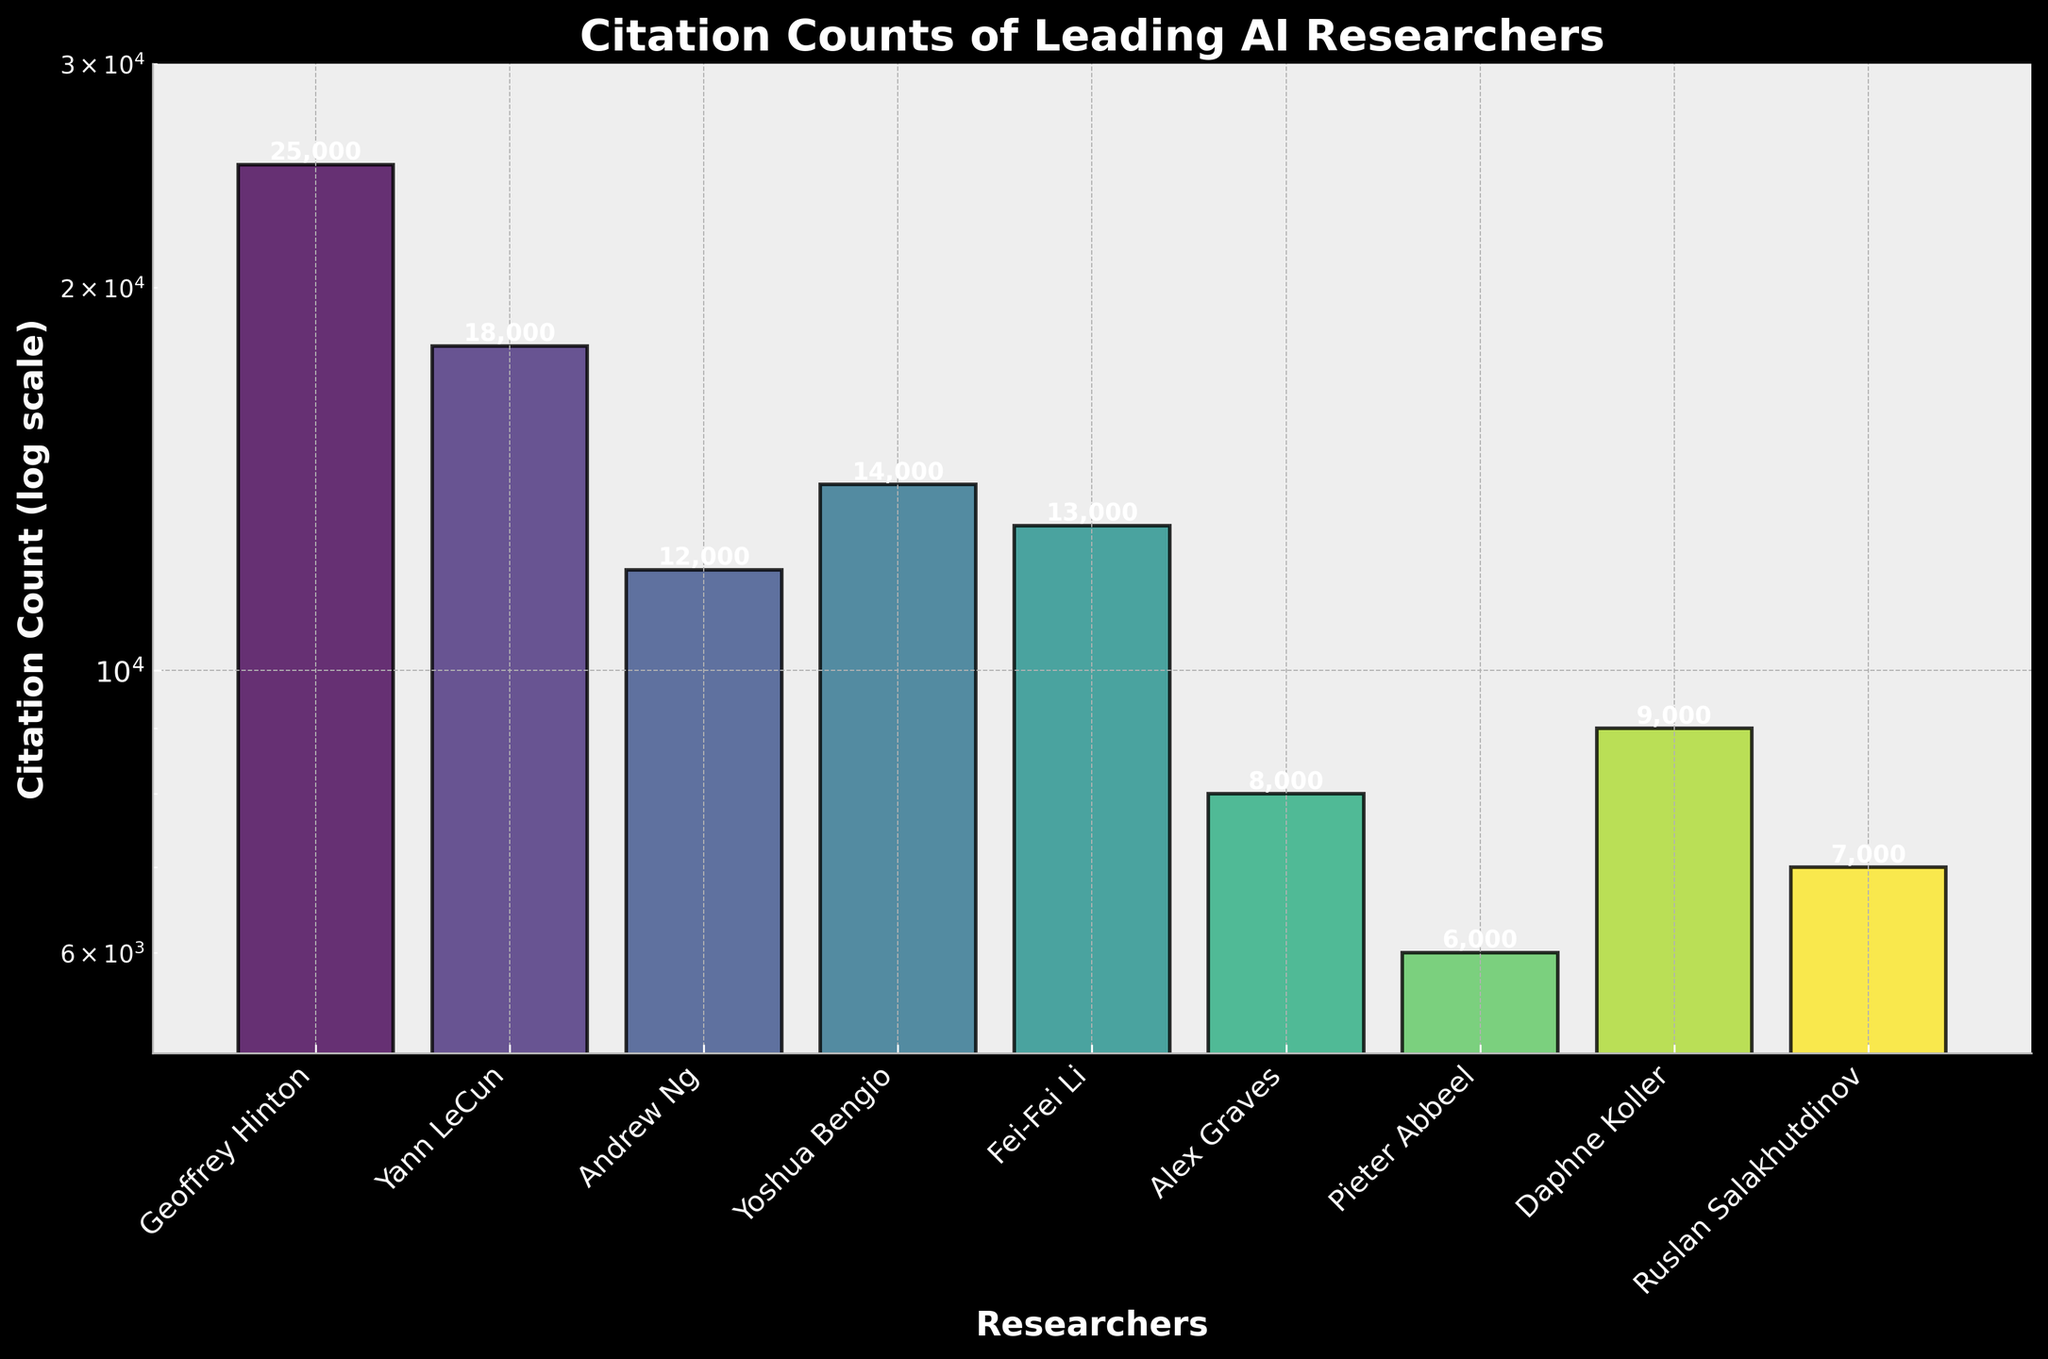what is the title of the figure? The title is usually located at the top of the figure, summarizing what the figure is about.
Answer: Citation Counts of Leading AI Researchers how many researchers have their citation counts displayed in the plot? Count the number of distinct names on the x-axis.
Answer: 9 which researcher has the highest citation count? Look for the bar that reaches the highest value on the y-axis.
Answer: Geoffrey Hinton which researcher has the lowest citation count? Identify the shortest bar on the plot.
Answer: Pieter Abbeel how many researchers have citation counts above 10,000? Count the number of bars that exceed the 10,000 mark on the y-axis.
Answer: 5 what’s the citation count difference between Andrew Ng and Daphne Koller? Subtract Koller’s citation count from Ng’s citation count. 12000 - 9000
Answer: 3000 are there any researchers with citation counts between 6,000 and 8,000? Identify the researchers whose bars fall within the specified range on the y-axis.
Answer: Alex Graves, Pieter Abbeel, Ruslan Salakhutdinov how does the citation count of Fei-Fei Li compare to that of Yoshua Bengio? Compare the heights of their respective bars. Li’s count is slightly lower.
Answer: lower if you were to sum up the citation counts of all researchers, what would the total be? Add up the citation counts of all researchers. 25000 + 18000 + 12000 + 14000 + 13000 + 8000 + 6000 + 9000 + 7000 = 112000
Answer: 112000 how does the use of a log scale affect the visual representation of the citation counts? A log scale makes it easier to see differences among values that span several orders of magnitude. It compresses large ranges to highlight smaller variations.
Answer: Compresses large ranges, highlights smaller variations 